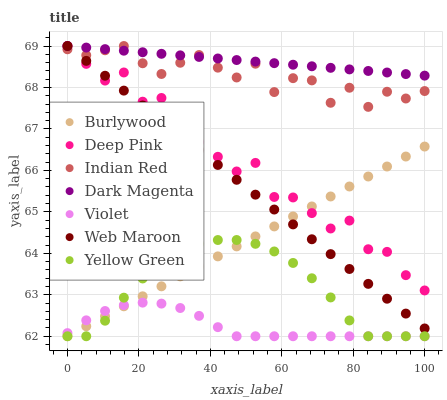Does Violet have the minimum area under the curve?
Answer yes or no. Yes. Does Dark Magenta have the maximum area under the curve?
Answer yes or no. Yes. Does Burlywood have the minimum area under the curve?
Answer yes or no. No. Does Burlywood have the maximum area under the curve?
Answer yes or no. No. Is Dark Magenta the smoothest?
Answer yes or no. Yes. Is Deep Pink the roughest?
Answer yes or no. Yes. Is Burlywood the smoothest?
Answer yes or no. No. Is Burlywood the roughest?
Answer yes or no. No. Does Burlywood have the lowest value?
Answer yes or no. Yes. Does Dark Magenta have the lowest value?
Answer yes or no. No. Does Indian Red have the highest value?
Answer yes or no. Yes. Does Burlywood have the highest value?
Answer yes or no. No. Is Yellow Green less than Dark Magenta?
Answer yes or no. Yes. Is Web Maroon greater than Yellow Green?
Answer yes or no. Yes. Does Dark Magenta intersect Deep Pink?
Answer yes or no. Yes. Is Dark Magenta less than Deep Pink?
Answer yes or no. No. Is Dark Magenta greater than Deep Pink?
Answer yes or no. No. Does Yellow Green intersect Dark Magenta?
Answer yes or no. No. 